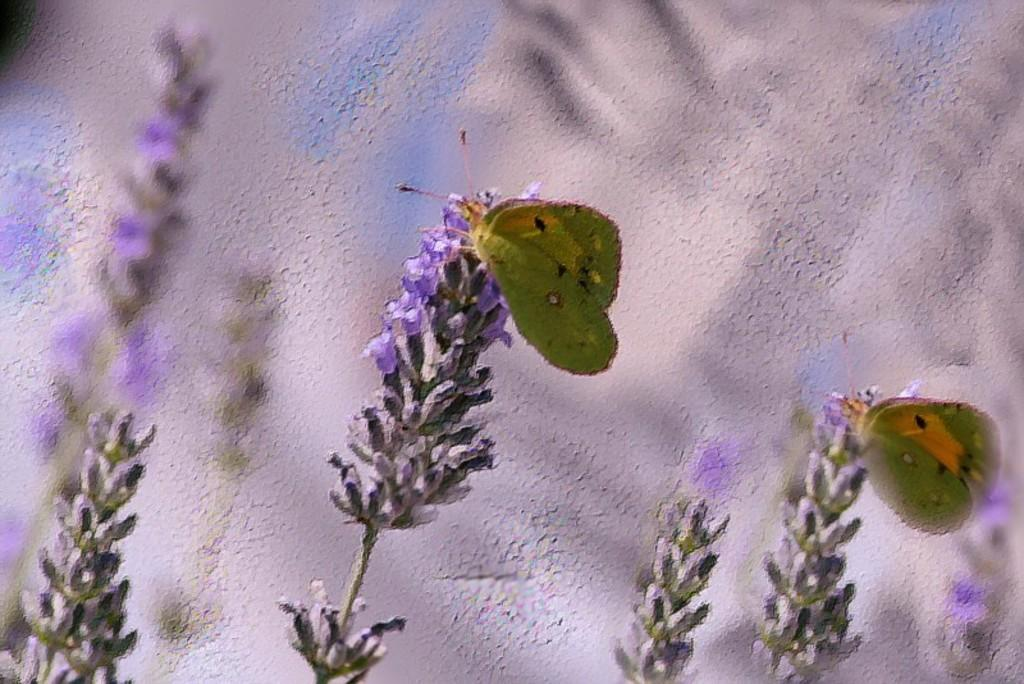What type of artwork is depicted in the image? The image appears to be a painting. What creatures can be seen in the painting? There are two insects in the painting. Where are the insects located in the painting? The insects are on flowers. What is visible behind the flowers in the painting? There is a wall visible behind the flowers. What type of pets are visible in the painting? There are no pets visible in the painting; it features insects on flowers. Can you tell me the title of the book the insects are reading in the painting? There is no book present in the painting, as it features insects on flowers and a wall in the background. 